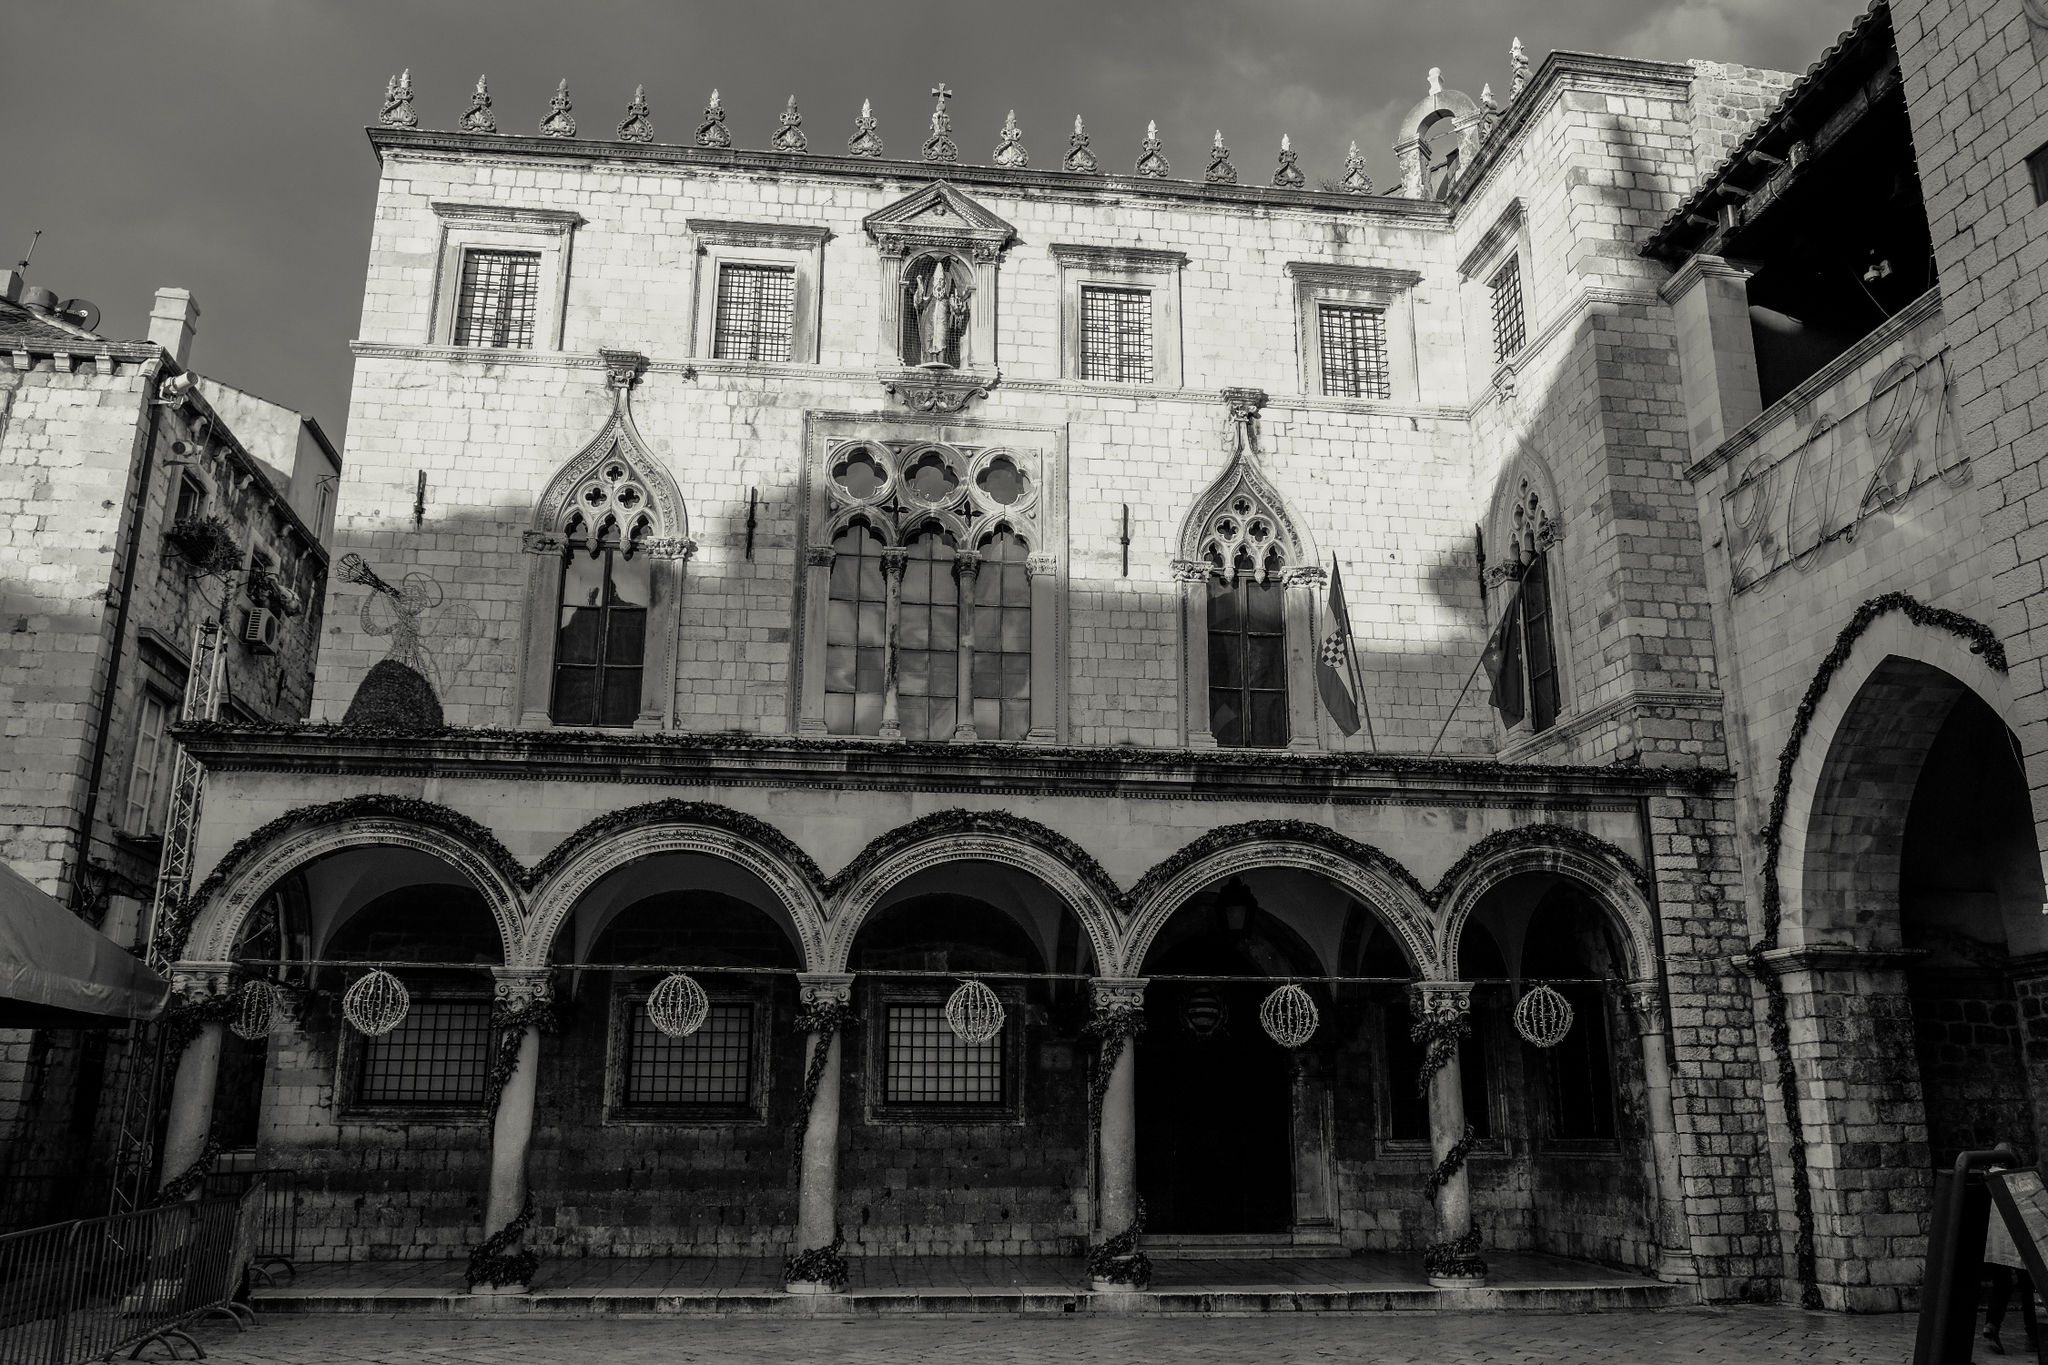Describe the historical significance of this building. The Rector's Palace in Dubrovnik, Croatia, holds immense historical significance as it was once the seat of the Rector of the Republic of Ragusa between the 14th and 19th centuries. This Gothic-Renaissance building symbolizes the political and economic strength of Dubrovnik during its glory days. The palace housed administrative offices and lodging for the rector during his one-month term of duty. It also included a courtroom, an arsenal, and a prison. This architectural masterpiece has survived through centuries of political changes, earthquakes, and fires, making it a resilient emblem of Dubrovnik's rich and storied past. What features of the palace stand out the most in this photo? In this photo, the most striking features of the Rector's Palace are the arched windows and the intricate Gothic and Renaissance details on the facade. The play of light and shadow highlights these architectural elements, creating a dramatic effect. The stone ornaments atop the building and the statues also stand out, adding a touch of grandeur and historical depth. The symmetrical design and the detailed stonework add to the aesthetic appeal, making these features truly captivating. Imagine what kind of stories or events could have taken place inside this palace? Inside the Rector's Palace, one could imagine various grand events and important decisions that shaped Dubrovnik's history. Lavish banquets and balls, attended by the city's elite and dignitaries, could have taken place in its opulent halls. The courtroom might have witnessed significant trials and the passing of decrees that affected the populace. The rector, a figure of authority, would have held council meetings, discussed diplomatic relations, and managed the defense strategies of the Republic of Ragusa. The palace might also have been a place of refuge during times of crises, with its sturdy walls safeguarding leaders and citizens alike. Exploring its corridors and chambers would reveal stories of power, politics, and daily lives that are woven into the fabric of Dubrovnik's history. Can you think of a fantasy scenario involving this palace? Absolutely! Imagine the Rector's Palace as the heart of a mystical kingdom. Legend has it that beneath its stone floors lies a hidden chamber that houses an ancient and powerful relic capable of controlling the elements. The kingdom's rulers, wise and noble, have protected this secret for centuries, passing down clues and keys through generations. One fateful night, during a grand ball, the palace comes alive as an enchanted creature - a majestic griffin - emerges from the shadows, seeking the relic. The brave rector and a chosen group of adventurers, equipped with magical artifacts, must decipher riddles hidden in the palace's architecture to reach the chamber before the griffin. As they navigate hidden passages and unravel ancient spells, they uncover not only the true power of the relic but also a prophecy that reveals the fate of their kingdom. The palace, with its maze of secrets and history, becomes the ultimate battleground for a clash between light and darkness. 